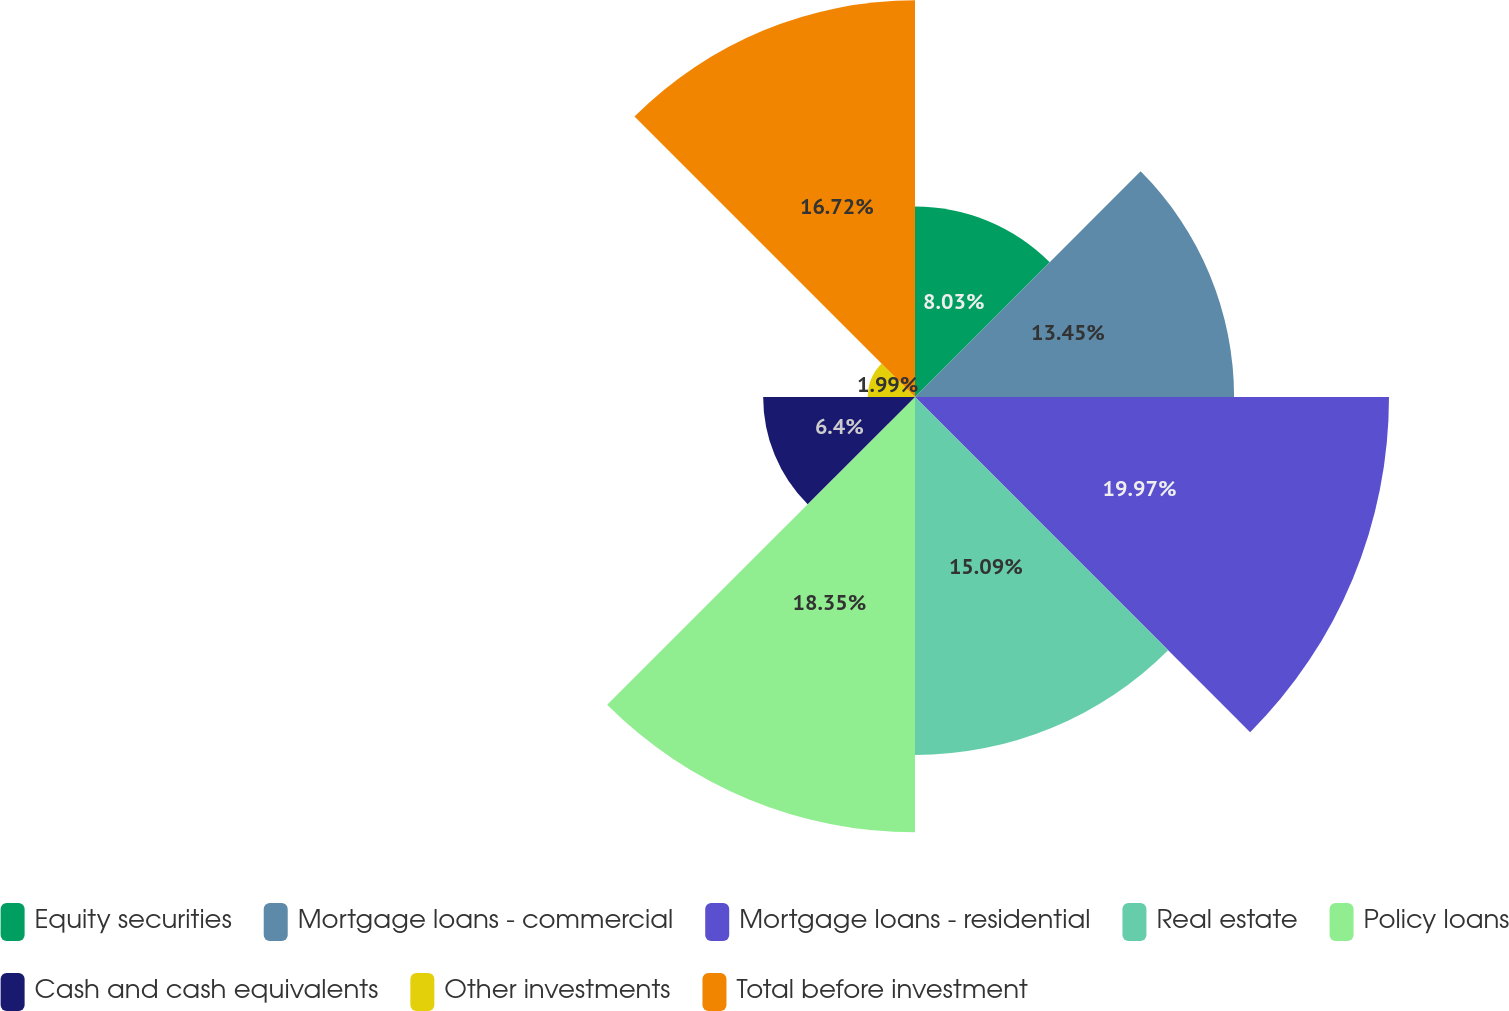Convert chart to OTSL. <chart><loc_0><loc_0><loc_500><loc_500><pie_chart><fcel>Equity securities<fcel>Mortgage loans - commercial<fcel>Mortgage loans - residential<fcel>Real estate<fcel>Policy loans<fcel>Cash and cash equivalents<fcel>Other investments<fcel>Total before investment<nl><fcel>8.03%<fcel>13.45%<fcel>19.98%<fcel>15.09%<fcel>18.35%<fcel>6.4%<fcel>1.99%<fcel>16.72%<nl></chart> 